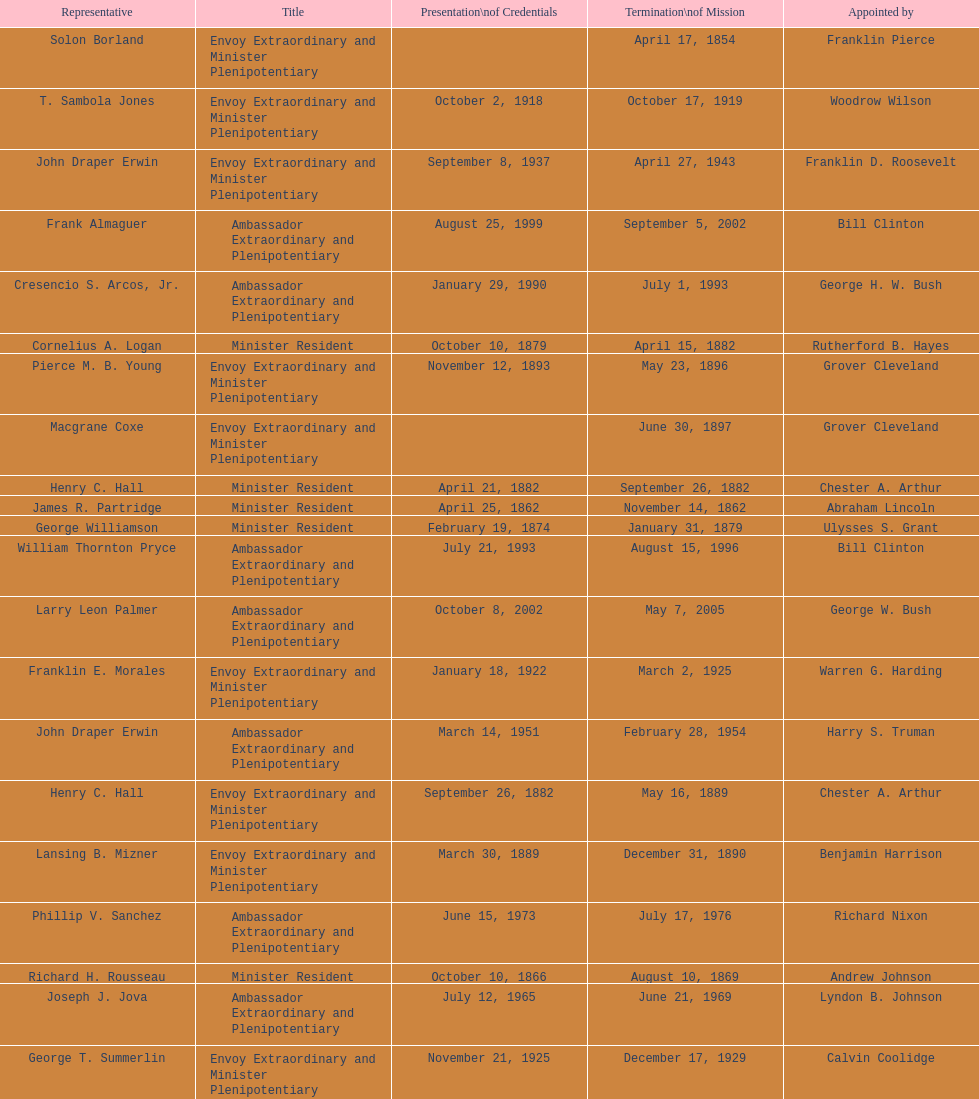What was the length, in years, of leslie combs' term? 4 years. Help me parse the entirety of this table. {'header': ['Representative', 'Title', 'Presentation\\nof Credentials', 'Termination\\nof Mission', 'Appointed by'], 'rows': [['Solon Borland', 'Envoy Extraordinary and Minister Plenipotentiary', '', 'April 17, 1854', 'Franklin Pierce'], ['T. Sambola Jones', 'Envoy Extraordinary and Minister Plenipotentiary', 'October 2, 1918', 'October 17, 1919', 'Woodrow Wilson'], ['John Draper Erwin', 'Envoy Extraordinary and Minister Plenipotentiary', 'September 8, 1937', 'April 27, 1943', 'Franklin D. Roosevelt'], ['Frank Almaguer', 'Ambassador Extraordinary and Plenipotentiary', 'August 25, 1999', 'September 5, 2002', 'Bill Clinton'], ['Cresencio S. Arcos, Jr.', 'Ambassador Extraordinary and Plenipotentiary', 'January 29, 1990', 'July 1, 1993', 'George H. W. Bush'], ['Cornelius A. Logan', 'Minister Resident', 'October 10, 1879', 'April 15, 1882', 'Rutherford B. Hayes'], ['Pierce M. B. Young', 'Envoy Extraordinary and Minister Plenipotentiary', 'November 12, 1893', 'May 23, 1896', 'Grover Cleveland'], ['Macgrane Coxe', 'Envoy Extraordinary and Minister Plenipotentiary', '', 'June 30, 1897', 'Grover Cleveland'], ['Henry C. Hall', 'Minister Resident', 'April 21, 1882', 'September 26, 1882', 'Chester A. Arthur'], ['James R. Partridge', 'Minister Resident', 'April 25, 1862', 'November 14, 1862', 'Abraham Lincoln'], ['George Williamson', 'Minister Resident', 'February 19, 1874', 'January 31, 1879', 'Ulysses S. Grant'], ['William Thornton Pryce', 'Ambassador Extraordinary and Plenipotentiary', 'July 21, 1993', 'August 15, 1996', 'Bill Clinton'], ['Larry Leon Palmer', 'Ambassador Extraordinary and Plenipotentiary', 'October 8, 2002', 'May 7, 2005', 'George W. Bush'], ['Franklin E. Morales', 'Envoy Extraordinary and Minister Plenipotentiary', 'January 18, 1922', 'March 2, 1925', 'Warren G. Harding'], ['John Draper Erwin', 'Ambassador Extraordinary and Plenipotentiary', 'March 14, 1951', 'February 28, 1954', 'Harry S. Truman'], ['Henry C. Hall', 'Envoy Extraordinary and Minister Plenipotentiary', 'September 26, 1882', 'May 16, 1889', 'Chester A. Arthur'], ['Lansing B. Mizner', 'Envoy Extraordinary and Minister Plenipotentiary', 'March 30, 1889', 'December 31, 1890', 'Benjamin Harrison'], ['Phillip V. Sanchez', 'Ambassador Extraordinary and Plenipotentiary', 'June 15, 1973', 'July 17, 1976', 'Richard Nixon'], ['Richard H. Rousseau', 'Minister Resident', 'October 10, 1866', 'August 10, 1869', 'Andrew Johnson'], ['Joseph J. Jova', 'Ambassador Extraordinary and Plenipotentiary', 'July 12, 1965', 'June 21, 1969', 'Lyndon B. Johnson'], ['George T. Summerlin', 'Envoy Extraordinary and Minister Plenipotentiary', 'November 21, 1925', 'December 17, 1929', 'Calvin Coolidge'], ['Hugo Llorens', 'Ambassador Extraordinary and Plenipotentiary', 'September 19, 2008', 'ca. July 2011', 'George W. Bush'], ['John D. Negroponte', 'Ambassador Extraordinary and Plenipotentiary', 'November 11, 1981', 'May 30, 1985', 'Ronald Reagan'], ['Mari-Luci Jaramillo', 'Ambassador Extraordinary and Plenipotentiary', 'October 27, 1977', 'September 19, 1980', 'Jimmy Carter'], ['Leo J. Keena', 'Envoy Extraordinary and Minister Plenipotentiary', 'July 19, 1935', 'May 1, 1937', 'Franklin D. Roosevelt'], ['John Draper Erwin', 'Ambassador Extraordinary and Plenipotentiary', 'April 27, 1943', 'April 16, 1947', 'Franklin D. Roosevelt'], ['W. Godfrey Hunter', 'Envoy Extraordinary and Minister Plenipotentiary', 'January 19, 1899', 'February 2, 1903', 'William McKinley'], ['Philip Marshall Brown', 'Envoy Extraordinary and Minister Plenipotentiary', 'February 21, 1909', 'February 26, 1910', 'Theodore Roosevelt'], ['Charles Dunning White', 'Envoy Extraordinary and Minister Plenipotentiary', 'September 9, 1911', 'November 4, 1913', 'William H. Taft'], ['Joseph W. J. Lee', 'Envoy Extraordinary and Minister Plenipotentiary', '', 'July 1, 1907', 'Theodore Roosevelt'], ['Leslie Combs', 'Envoy Extraordinary and Minister Plenipotentiary', 'May 22, 1903', 'February 27, 1907', 'Theodore Roosevelt'], ['Whiting Willauer', 'Ambassador Extraordinary and Plenipotentiary', 'March 5, 1954', 'March 24, 1958', 'Dwight D. Eisenhower'], ['Ralph E. Becker', 'Ambassador Extraordinary and Plenipotentiary', 'October 27, 1976', 'August 1, 1977', 'Gerald Ford'], ['Herbert S. Bursley', 'Ambassador Extraordinary and Plenipotentiary', 'May 15, 1948', 'December 12, 1950', 'Harry S. Truman'], ['Romualdo Pacheco', 'Envoy Extraordinary and Minister Plenipotentiary', 'April 17, 1891', 'June 12, 1893', 'Benjamin Harrison'], ['Charles A. Ford', 'Ambassador Extraordinary and Plenipotentiary', 'November 8, 2005', 'ca. April 2008', 'George W. Bush'], ['Charles R. Burrows', 'Ambassador Extraordinary and Plenipotentiary', 'November 3, 1960', 'June 28, 1965', 'Dwight D. Eisenhower'], ['Beverly L. Clarke', 'Minister Resident', 'August 10, 1858', 'March 17, 1860', 'James Buchanan'], ['Fenton R. McCreery', 'Envoy Extraordinary and Minister Plenipotentiary', 'March 10, 1910', 'July 2, 1911', 'William H. Taft'], ['H. Percival Dodge', 'Envoy Extraordinary and Minister Plenipotentiary', 'June 17, 1908', 'February 6, 1909', 'Theodore Roosevelt'], ['Everett Ellis Briggs', 'Ambassador Extraordinary and Plenipotentiary', 'November 4, 1986', 'June 15, 1989', 'Ronald Reagan'], ['Hewson A. Ryan', 'Ambassador Extraordinary and Plenipotentiary', 'November 5, 1969', 'May 30, 1973', 'Richard Nixon'], ['Paul C. Daniels', 'Ambassador Extraordinary and Plenipotentiary', 'June 23, 1947', 'October 30, 1947', 'Harry S. Truman'], ['Jack R. Binns', 'Ambassador Extraordinary and Plenipotentiary', 'October 10, 1980', 'October 31, 1981', 'Jimmy Carter'], ['Julius G. Lay', 'Envoy Extraordinary and Minister Plenipotentiary', 'May 31, 1930', 'March 17, 1935', 'Herbert Hoover'], ['Robert Newbegin', 'Ambassador Extraordinary and Plenipotentiary', 'April 30, 1958', 'August 3, 1960', 'Dwight D. Eisenhower'], ['John Ewing', 'Envoy Extraordinary and Minister Plenipotentiary', 'December 26, 1913', 'January 18, 1918', 'Woodrow Wilson'], ['Thomas H. Clay', 'Minister Resident', 'April 5, 1864', 'August 10, 1866', 'Abraham Lincoln'], ['Henry Baxter', 'Minister Resident', 'August 10, 1869', 'June 30, 1873', 'Ulysses S. Grant'], ['Lisa Kubiske', 'Ambassador Extraordinary and Plenipotentiary', 'July 26, 2011', 'Incumbent', 'Barack Obama'], ['John Arthur Ferch', 'Ambassador Extraordinary and Plenipotentiary', 'August 22, 1985', 'July 9, 1986', 'Ronald Reagan'], ['James F. Creagan', 'Ambassador Extraordinary and Plenipotentiary', 'August 29, 1996', 'July 20, 1999', 'Bill Clinton']]} 